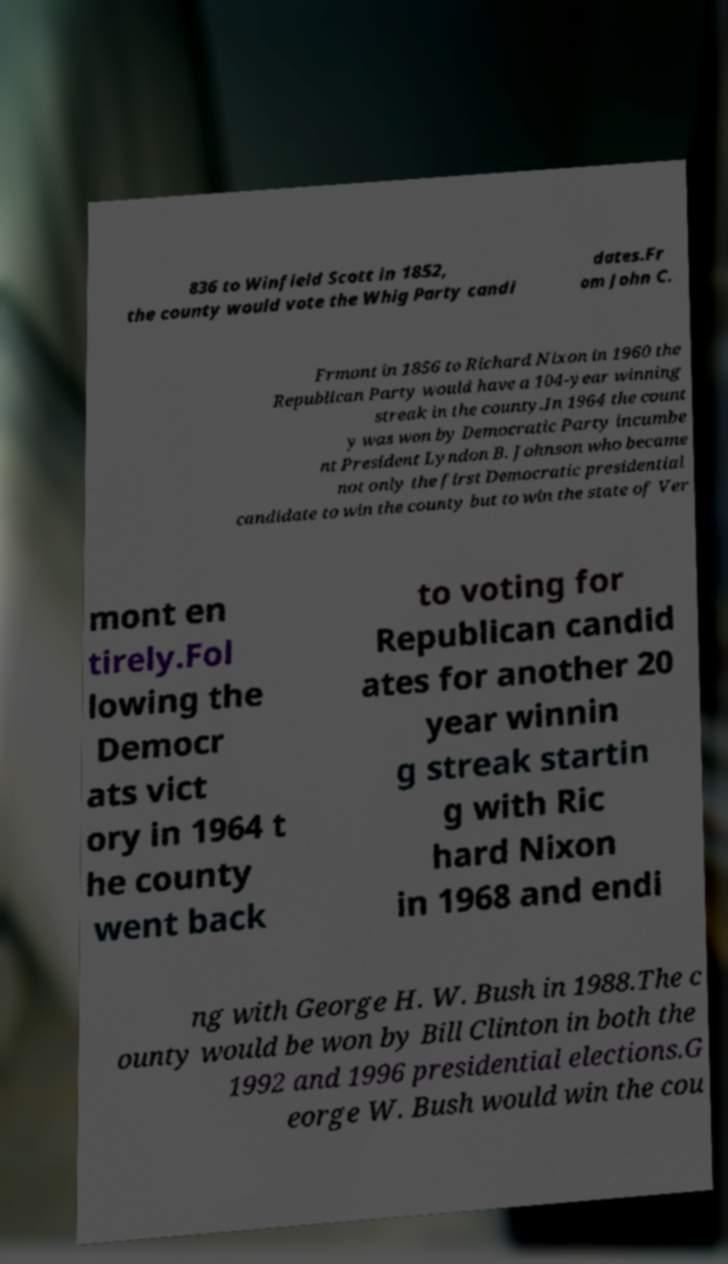For documentation purposes, I need the text within this image transcribed. Could you provide that? 836 to Winfield Scott in 1852, the county would vote the Whig Party candi dates.Fr om John C. Frmont in 1856 to Richard Nixon in 1960 the Republican Party would have a 104-year winning streak in the county.In 1964 the count y was won by Democratic Party incumbe nt President Lyndon B. Johnson who became not only the first Democratic presidential candidate to win the county but to win the state of Ver mont en tirely.Fol lowing the Democr ats vict ory in 1964 t he county went back to voting for Republican candid ates for another 20 year winnin g streak startin g with Ric hard Nixon in 1968 and endi ng with George H. W. Bush in 1988.The c ounty would be won by Bill Clinton in both the 1992 and 1996 presidential elections.G eorge W. Bush would win the cou 